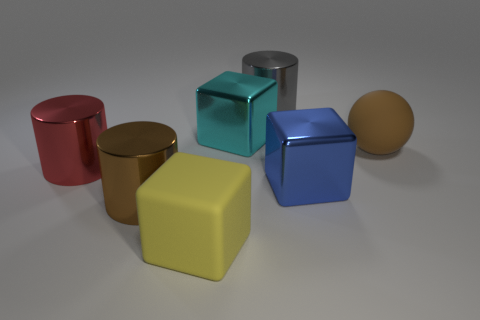Add 2 big things. How many objects exist? 9 Subtract all spheres. How many objects are left? 6 Subtract all small purple shiny balls. Subtract all big brown metal cylinders. How many objects are left? 6 Add 2 red things. How many red things are left? 3 Add 4 shiny cylinders. How many shiny cylinders exist? 7 Subtract 0 yellow balls. How many objects are left? 7 